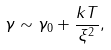<formula> <loc_0><loc_0><loc_500><loc_500>\gamma \sim \gamma _ { 0 } + \frac { k T } { \xi ^ { 2 } } ,</formula> 